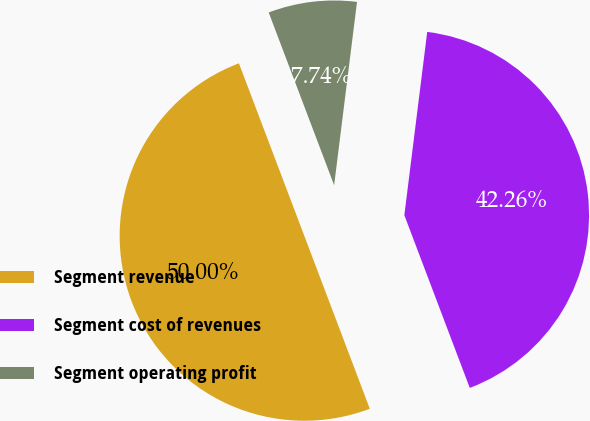Convert chart to OTSL. <chart><loc_0><loc_0><loc_500><loc_500><pie_chart><fcel>Segment revenue<fcel>Segment cost of revenues<fcel>Segment operating profit<nl><fcel>50.0%<fcel>42.26%<fcel>7.74%<nl></chart> 